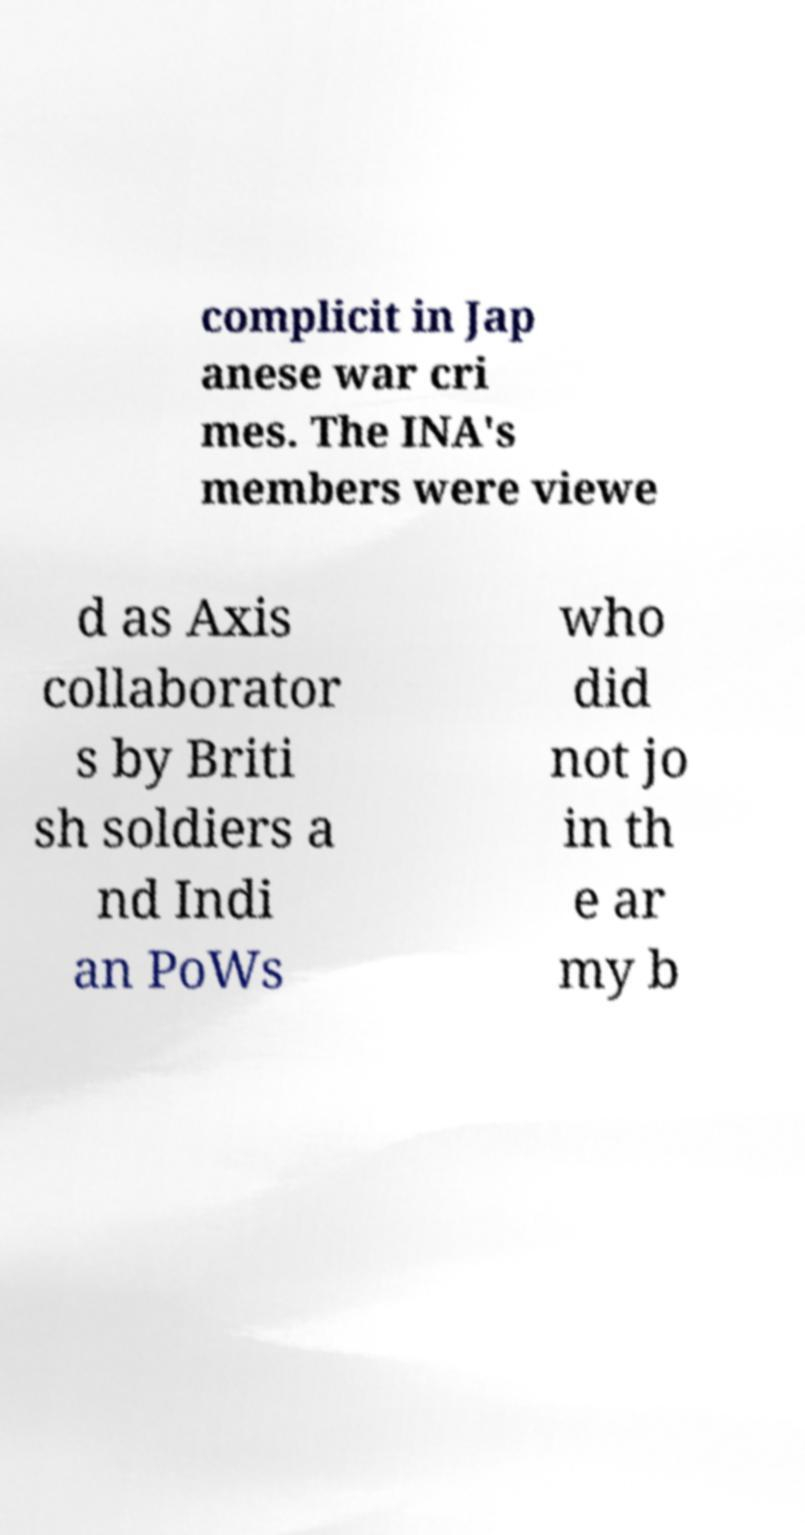Please identify and transcribe the text found in this image. complicit in Jap anese war cri mes. The INA's members were viewe d as Axis collaborator s by Briti sh soldiers a nd Indi an PoWs who did not jo in th e ar my b 